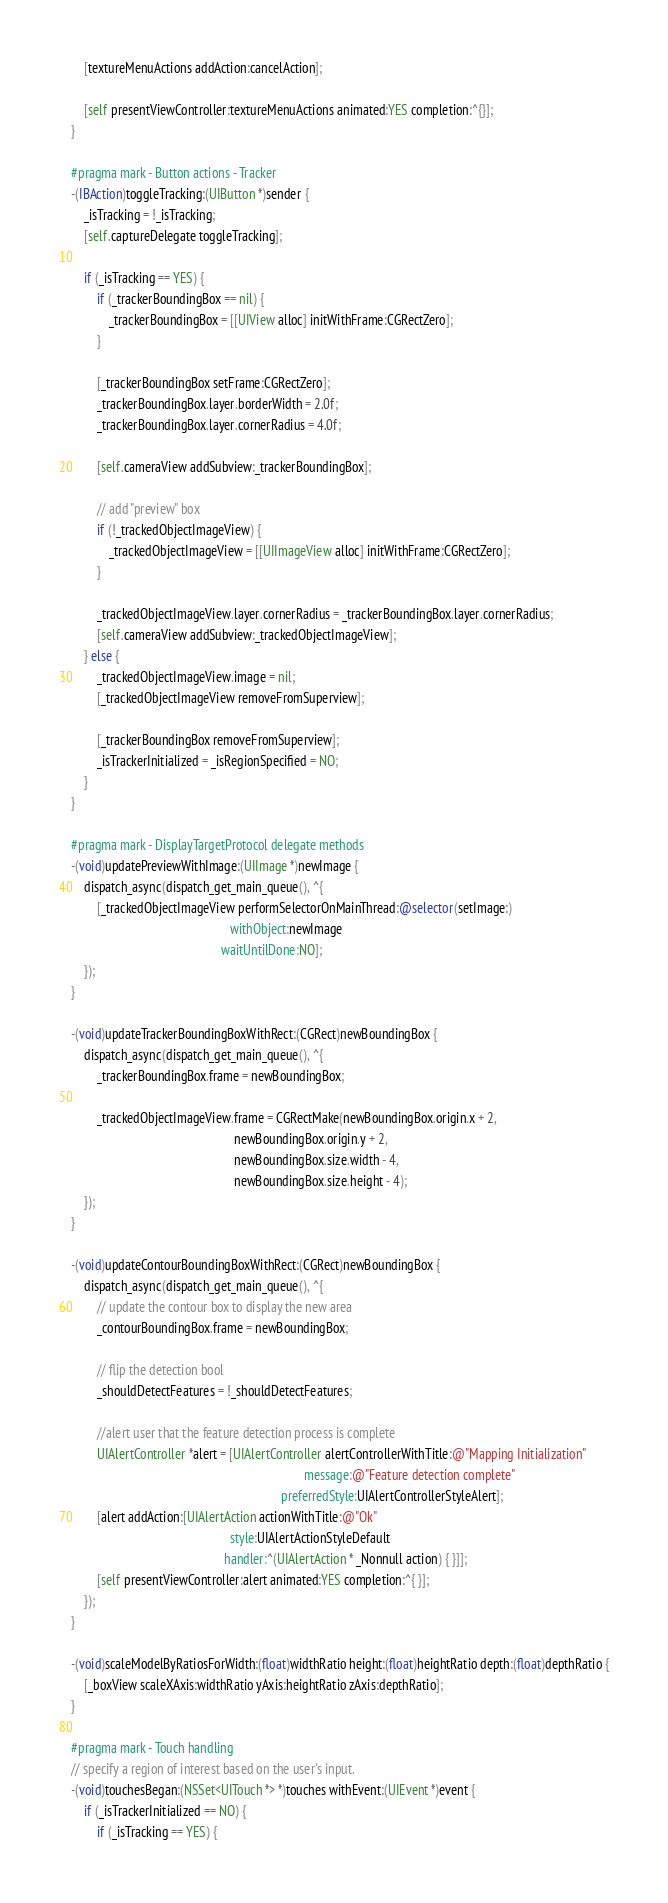<code> <loc_0><loc_0><loc_500><loc_500><_ObjectiveC_>    [textureMenuActions addAction:cancelAction];

    [self presentViewController:textureMenuActions animated:YES completion:^{}];
}

#pragma mark - Button actions - Tracker
-(IBAction)toggleTracking:(UIButton *)sender {
    _isTracking = !_isTracking;
    [self.captureDelegate toggleTracking];

    if (_isTracking == YES) {
        if (_trackerBoundingBox == nil) {
            _trackerBoundingBox = [[UIView alloc] initWithFrame:CGRectZero];
        }

        [_trackerBoundingBox setFrame:CGRectZero];
        _trackerBoundingBox.layer.borderWidth = 2.0f;
        _trackerBoundingBox.layer.cornerRadius = 4.0f;

        [self.cameraView addSubview:_trackerBoundingBox];

        // add "preview" box
        if (!_trackedObjectImageView) {
            _trackedObjectImageView = [[UIImageView alloc] initWithFrame:CGRectZero];
        }

        _trackedObjectImageView.layer.cornerRadius = _trackerBoundingBox.layer.cornerRadius;
        [self.cameraView addSubview:_trackedObjectImageView];
    } else {
        _trackedObjectImageView.image = nil;
        [_trackedObjectImageView removeFromSuperview];

        [_trackerBoundingBox removeFromSuperview];
        _isTrackerInitialized = _isRegionSpecified = NO;
    }
}

#pragma mark - DisplayTargetProtocol delegate methods
-(void)updatePreviewWithImage:(UIImage *)newImage {
    dispatch_async(dispatch_get_main_queue(), ^{
        [_trackedObjectImageView performSelectorOnMainThread:@selector(setImage:)
                                                  withObject:newImage
                                               waitUntilDone:NO];
    });
}

-(void)updateTrackerBoundingBoxWithRect:(CGRect)newBoundingBox {
    dispatch_async(dispatch_get_main_queue(), ^{
        _trackerBoundingBox.frame = newBoundingBox;

        _trackedObjectImageView.frame = CGRectMake(newBoundingBox.origin.x + 2,
                                                   newBoundingBox.origin.y + 2,
                                                   newBoundingBox.size.width - 4,
                                                   newBoundingBox.size.height - 4);
    });
}

-(void)updateContourBoundingBoxWithRect:(CGRect)newBoundingBox {
    dispatch_async(dispatch_get_main_queue(), ^{
        // update the contour box to display the new area
        _contourBoundingBox.frame = newBoundingBox;

        // flip the detection bool
        _shouldDetectFeatures = !_shouldDetectFeatures;

        //alert user that the feature detection process is complete
        UIAlertController *alert = [UIAlertController alertControllerWithTitle:@"Mapping Initialization"
                                                                         message:@"Feature detection complete"
                                                                  preferredStyle:UIAlertControllerStyleAlert];
        [alert addAction:[UIAlertAction actionWithTitle:@"Ok"
                                                  style:UIAlertActionStyleDefault
                                                handler:^(UIAlertAction * _Nonnull action) { }]];
        [self presentViewController:alert animated:YES completion:^{ }];
    });
}

-(void)scaleModelByRatiosForWidth:(float)widthRatio height:(float)heightRatio depth:(float)depthRatio {
    [_boxView scaleXAxis:widthRatio yAxis:heightRatio zAxis:depthRatio];
}

#pragma mark - Touch handling
// specify a region of interest based on the user's input.
-(void)touchesBegan:(NSSet<UITouch *> *)touches withEvent:(UIEvent *)event {
    if (_isTrackerInitialized == NO) {
        if (_isTracking == YES) {</code> 